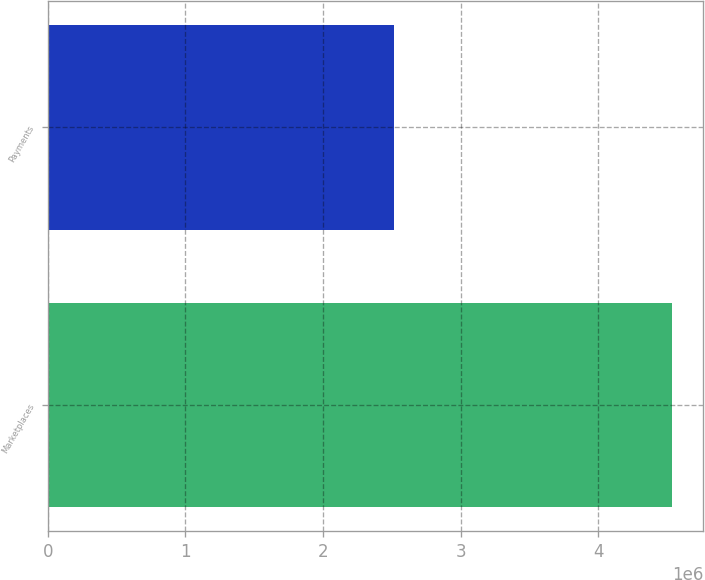Convert chart. <chart><loc_0><loc_0><loc_500><loc_500><bar_chart><fcel>Marketplaces<fcel>Payments<nl><fcel>4.53679e+06<fcel>2.51512e+06<nl></chart> 